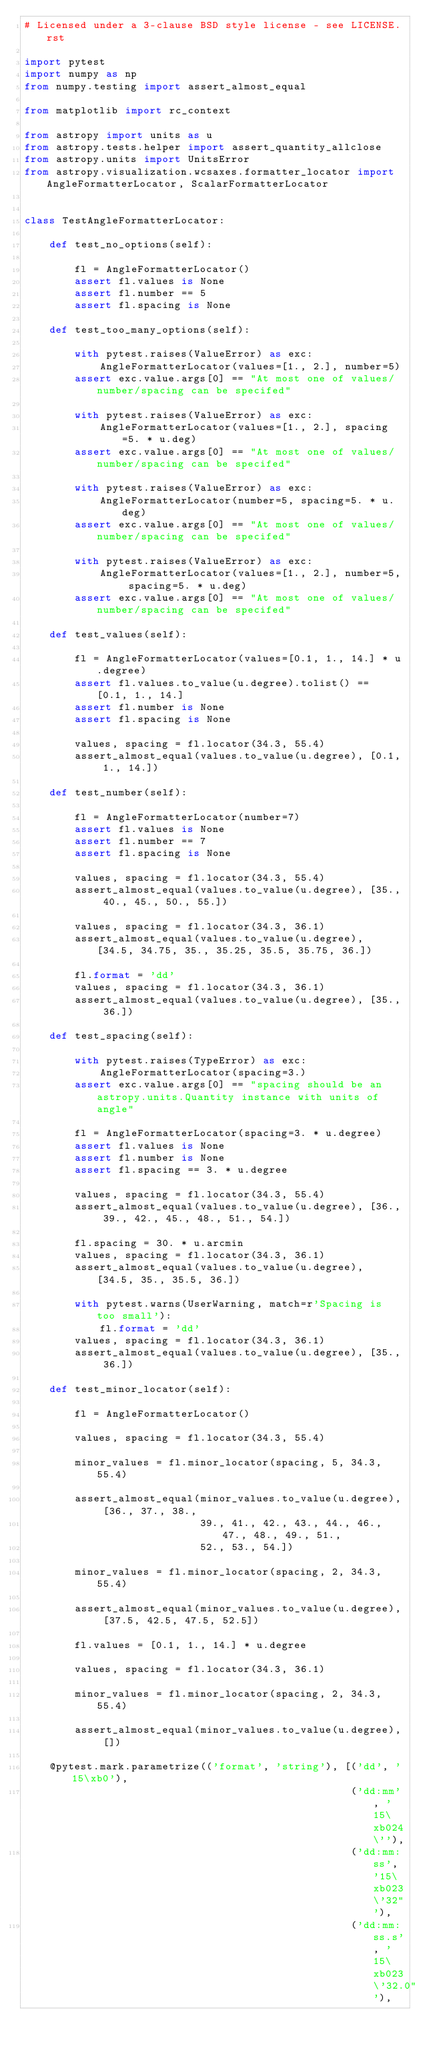<code> <loc_0><loc_0><loc_500><loc_500><_Python_># Licensed under a 3-clause BSD style license - see LICENSE.rst

import pytest
import numpy as np
from numpy.testing import assert_almost_equal

from matplotlib import rc_context

from astropy import units as u
from astropy.tests.helper import assert_quantity_allclose
from astropy.units import UnitsError
from astropy.visualization.wcsaxes.formatter_locator import AngleFormatterLocator, ScalarFormatterLocator


class TestAngleFormatterLocator:

    def test_no_options(self):

        fl = AngleFormatterLocator()
        assert fl.values is None
        assert fl.number == 5
        assert fl.spacing is None

    def test_too_many_options(self):

        with pytest.raises(ValueError) as exc:
            AngleFormatterLocator(values=[1., 2.], number=5)
        assert exc.value.args[0] == "At most one of values/number/spacing can be specifed"

        with pytest.raises(ValueError) as exc:
            AngleFormatterLocator(values=[1., 2.], spacing=5. * u.deg)
        assert exc.value.args[0] == "At most one of values/number/spacing can be specifed"

        with pytest.raises(ValueError) as exc:
            AngleFormatterLocator(number=5, spacing=5. * u.deg)
        assert exc.value.args[0] == "At most one of values/number/spacing can be specifed"

        with pytest.raises(ValueError) as exc:
            AngleFormatterLocator(values=[1., 2.], number=5, spacing=5. * u.deg)
        assert exc.value.args[0] == "At most one of values/number/spacing can be specifed"

    def test_values(self):

        fl = AngleFormatterLocator(values=[0.1, 1., 14.] * u.degree)
        assert fl.values.to_value(u.degree).tolist() == [0.1, 1., 14.]
        assert fl.number is None
        assert fl.spacing is None

        values, spacing = fl.locator(34.3, 55.4)
        assert_almost_equal(values.to_value(u.degree), [0.1, 1., 14.])

    def test_number(self):

        fl = AngleFormatterLocator(number=7)
        assert fl.values is None
        assert fl.number == 7
        assert fl.spacing is None

        values, spacing = fl.locator(34.3, 55.4)
        assert_almost_equal(values.to_value(u.degree), [35., 40., 45., 50., 55.])

        values, spacing = fl.locator(34.3, 36.1)
        assert_almost_equal(values.to_value(u.degree), [34.5, 34.75, 35., 35.25, 35.5, 35.75, 36.])

        fl.format = 'dd'
        values, spacing = fl.locator(34.3, 36.1)
        assert_almost_equal(values.to_value(u.degree), [35., 36.])

    def test_spacing(self):

        with pytest.raises(TypeError) as exc:
            AngleFormatterLocator(spacing=3.)
        assert exc.value.args[0] == "spacing should be an astropy.units.Quantity instance with units of angle"

        fl = AngleFormatterLocator(spacing=3. * u.degree)
        assert fl.values is None
        assert fl.number is None
        assert fl.spacing == 3. * u.degree

        values, spacing = fl.locator(34.3, 55.4)
        assert_almost_equal(values.to_value(u.degree), [36., 39., 42., 45., 48., 51., 54.])

        fl.spacing = 30. * u.arcmin
        values, spacing = fl.locator(34.3, 36.1)
        assert_almost_equal(values.to_value(u.degree), [34.5, 35., 35.5, 36.])

        with pytest.warns(UserWarning, match=r'Spacing is too small'):
            fl.format = 'dd'
        values, spacing = fl.locator(34.3, 36.1)
        assert_almost_equal(values.to_value(u.degree), [35., 36.])

    def test_minor_locator(self):

        fl = AngleFormatterLocator()

        values, spacing = fl.locator(34.3, 55.4)

        minor_values = fl.minor_locator(spacing, 5, 34.3, 55.4)

        assert_almost_equal(minor_values.to_value(u.degree), [36., 37., 38.,
                            39., 41., 42., 43., 44., 46., 47., 48., 49., 51.,
                            52., 53., 54.])

        minor_values = fl.minor_locator(spacing, 2, 34.3, 55.4)

        assert_almost_equal(minor_values.to_value(u.degree), [37.5, 42.5, 47.5, 52.5])

        fl.values = [0.1, 1., 14.] * u.degree

        values, spacing = fl.locator(34.3, 36.1)

        minor_values = fl.minor_locator(spacing, 2, 34.3, 55.4)

        assert_almost_equal(minor_values.to_value(u.degree), [])

    @pytest.mark.parametrize(('format', 'string'), [('dd', '15\xb0'),
                                                    ('dd:mm', '15\xb024\''),
                                                    ('dd:mm:ss', '15\xb023\'32"'),
                                                    ('dd:mm:ss.s', '15\xb023\'32.0"'),</code> 